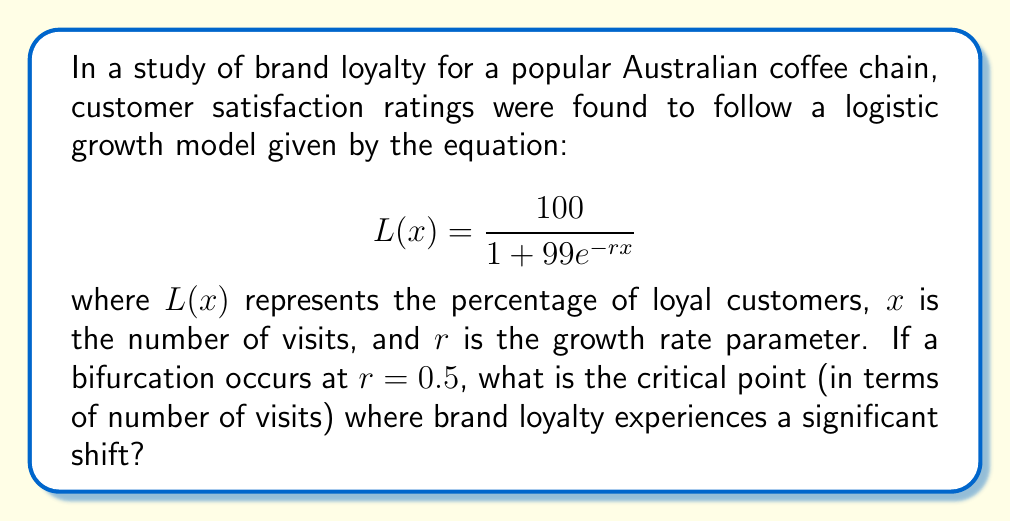Show me your answer to this math problem. To find the critical point where brand loyalty experiences a significant shift, we need to analyze the bifurcation point of the logistic growth model. Here's a step-by-step approach:

1) In a logistic growth model, the inflection point occurs at half the carrying capacity. In this case, the carrying capacity is 100% (maximum loyalty).

2) Set $L(x) = 50$ (half of the carrying capacity):

   $$50 = \frac{100}{1 + 99e^{-rx}}$$

3) Solve for $x$:
   
   $$1 + 99e^{-rx} = 2$$
   $$99e^{-rx} = 1$$
   $$e^{-rx} = \frac{1}{99}$$
   $$-rx = \ln(\frac{1}{99})$$
   $$x = -\frac{\ln(\frac{1}{99})}{r}$$

4) Given that bifurcation occurs at $r = 0.5$, substitute this value:

   $$x = -\frac{\ln(\frac{1}{99})}{0.5}$$

5) Simplify:
   
   $$x = -2\ln(\frac{1}{99}) = 2\ln(99) \approx 9.19$$

This value of $x$ represents the number of visits at which brand loyalty experiences a significant shift.
Answer: $2\ln(99) \approx 9.19$ visits 